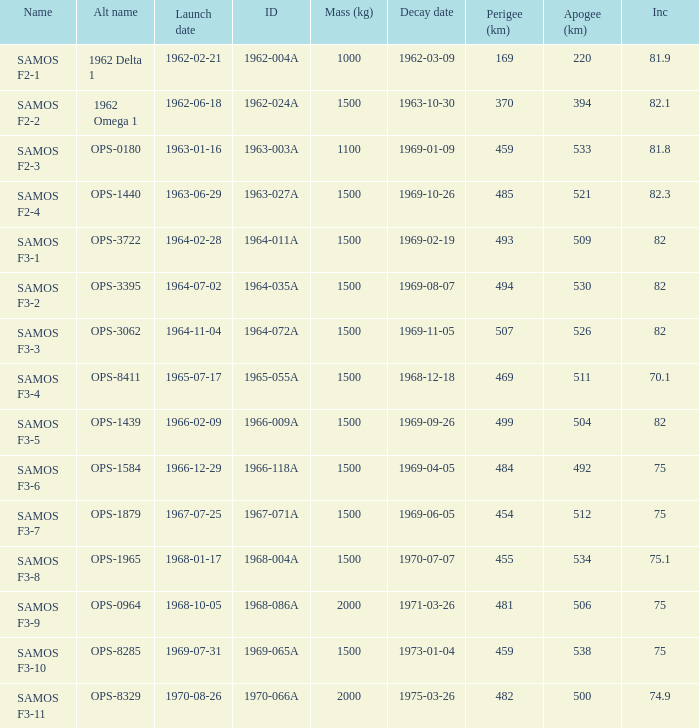What is the inclination when the alt name is OPS-1584? 75.0. Would you mind parsing the complete table? {'header': ['Name', 'Alt name', 'Launch date', 'ID', 'Mass (kg)', 'Decay date', 'Perigee (km)', 'Apogee (km)', 'Inc'], 'rows': [['SAMOS F2-1', '1962 Delta 1', '1962-02-21', '1962-004A', '1000', '1962-03-09', '169', '220', '81.9'], ['SAMOS F2-2', '1962 Omega 1', '1962-06-18', '1962-024A', '1500', '1963-10-30', '370', '394', '82.1'], ['SAMOS F2-3', 'OPS-0180', '1963-01-16', '1963-003A', '1100', '1969-01-09', '459', '533', '81.8'], ['SAMOS F2-4', 'OPS-1440', '1963-06-29', '1963-027A', '1500', '1969-10-26', '485', '521', '82.3'], ['SAMOS F3-1', 'OPS-3722', '1964-02-28', '1964-011A', '1500', '1969-02-19', '493', '509', '82'], ['SAMOS F3-2', 'OPS-3395', '1964-07-02', '1964-035A', '1500', '1969-08-07', '494', '530', '82'], ['SAMOS F3-3', 'OPS-3062', '1964-11-04', '1964-072A', '1500', '1969-11-05', '507', '526', '82'], ['SAMOS F3-4', 'OPS-8411', '1965-07-17', '1965-055A', '1500', '1968-12-18', '469', '511', '70.1'], ['SAMOS F3-5', 'OPS-1439', '1966-02-09', '1966-009A', '1500', '1969-09-26', '499', '504', '82'], ['SAMOS F3-6', 'OPS-1584', '1966-12-29', '1966-118A', '1500', '1969-04-05', '484', '492', '75'], ['SAMOS F3-7', 'OPS-1879', '1967-07-25', '1967-071A', '1500', '1969-06-05', '454', '512', '75'], ['SAMOS F3-8', 'OPS-1965', '1968-01-17', '1968-004A', '1500', '1970-07-07', '455', '534', '75.1'], ['SAMOS F3-9', 'OPS-0964', '1968-10-05', '1968-086A', '2000', '1971-03-26', '481', '506', '75'], ['SAMOS F3-10', 'OPS-8285', '1969-07-31', '1969-065A', '1500', '1973-01-04', '459', '538', '75'], ['SAMOS F3-11', 'OPS-8329', '1970-08-26', '1970-066A', '2000', '1975-03-26', '482', '500', '74.9']]} 